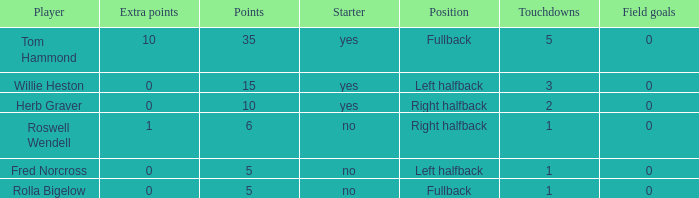What is the lowest number of field goals for a player with 3 touchdowns? 0.0. 